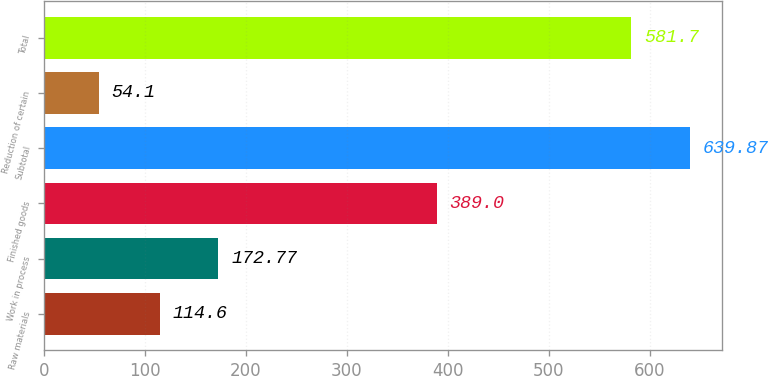<chart> <loc_0><loc_0><loc_500><loc_500><bar_chart><fcel>Raw materials<fcel>Work in process<fcel>Finished goods<fcel>Subtotal<fcel>Reduction of certain<fcel>Total<nl><fcel>114.6<fcel>172.77<fcel>389<fcel>639.87<fcel>54.1<fcel>581.7<nl></chart> 